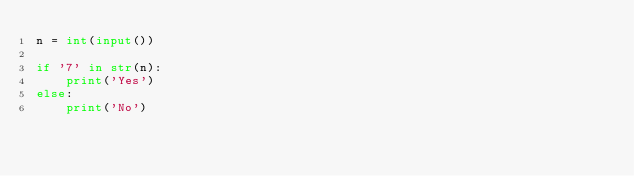<code> <loc_0><loc_0><loc_500><loc_500><_Python_>n = int(input())

if '7' in str(n):
    print('Yes')
else:
    print('No')</code> 